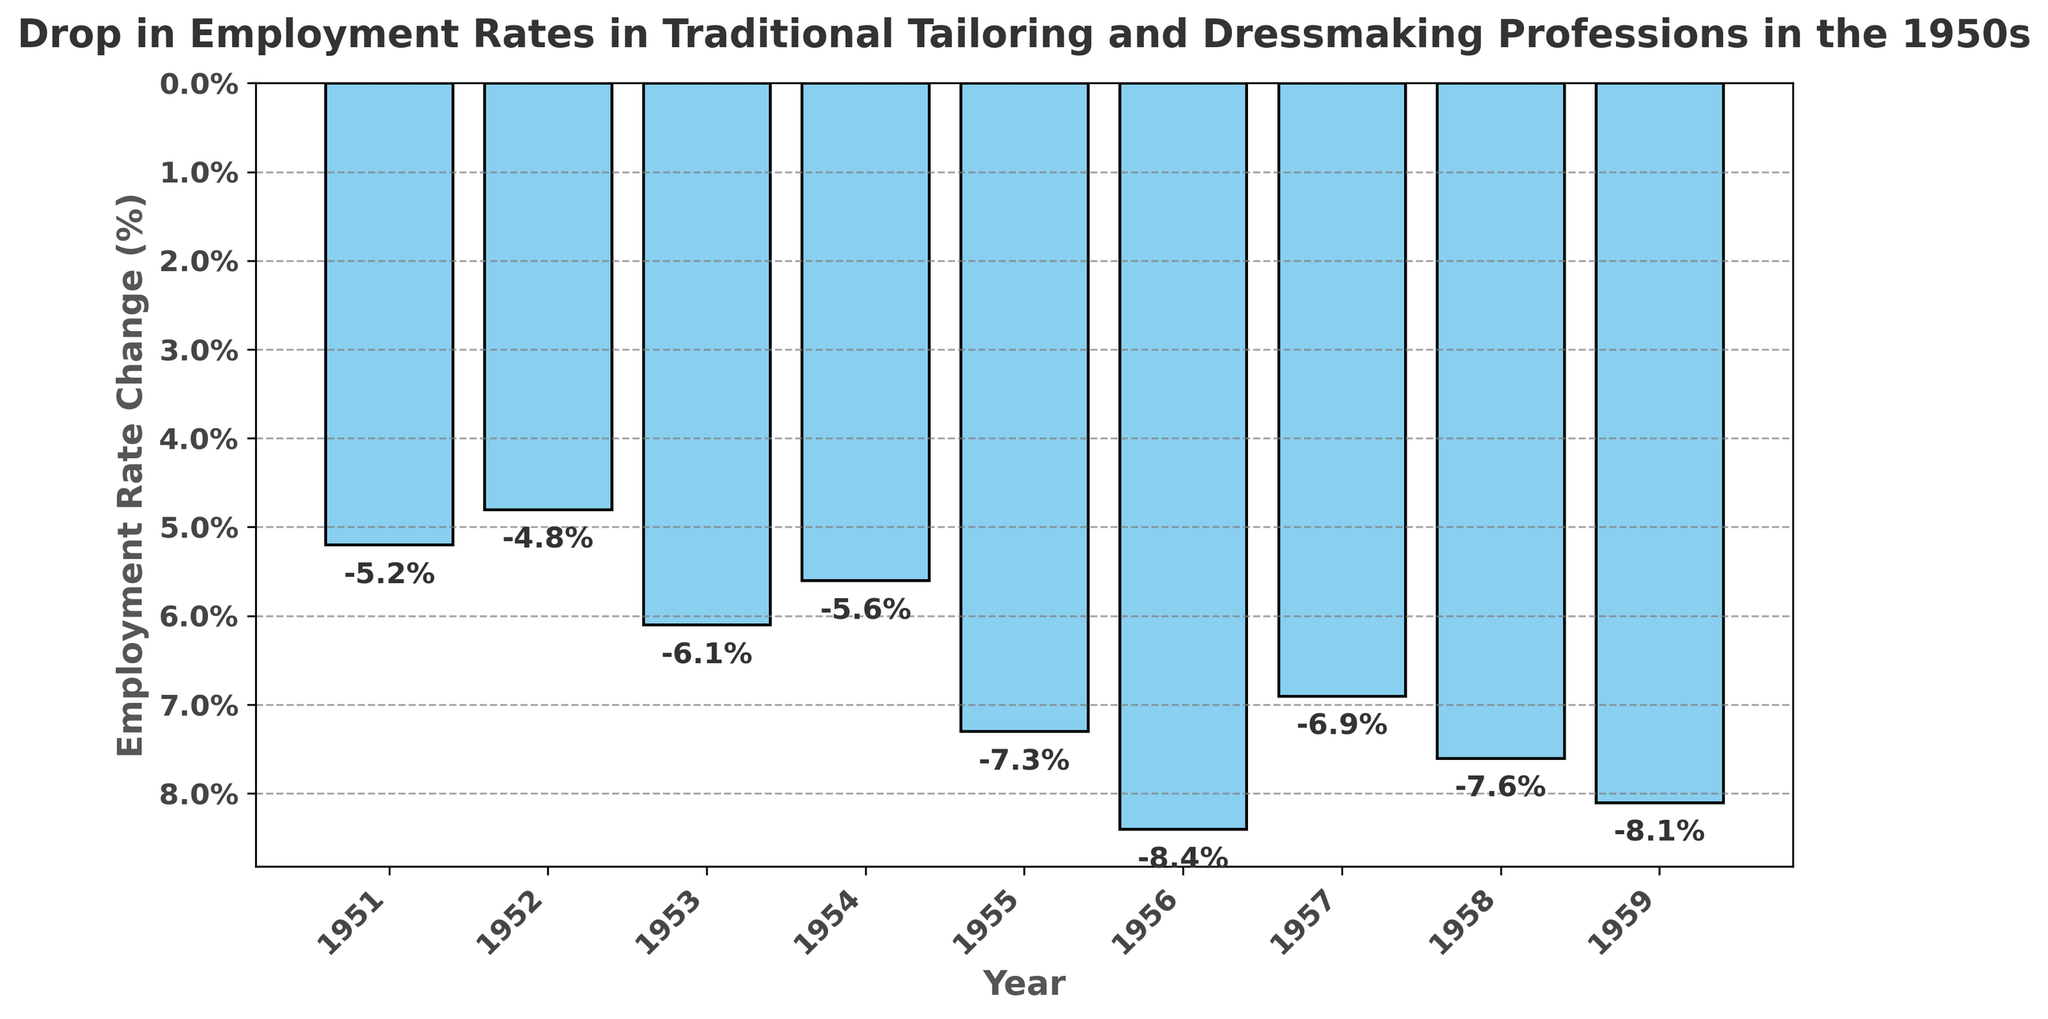What is the average drop in employment rate over the decade? To get the average drop, sum up all the employment rate changes and divide by the number of years. The total drop is (-5.2) + (-4.8) + (-6.1) + (-5.6) + (-7.3) + (-8.4) + (-6.9) + (-7.6) + (-8.1) = -60.0. There are 9 years, so the average drop is -60.0 / 9 = -6.67.
Answer: -6.67% Between which years did the largest single-year drop in employment rate occur? By examining the height of the bars, the largest single-year drop occurs between 1955 and 1956 where the drop changed from -7.3% to -8.4%, a difference of 1.1 percentage points.
Answer: 1955 to 1956 Which year had the smallest decrease in the employment rate? The year with the shortest bar represents the smallest decrease in the employment rate, which visually is 1952 with a drop of -4.8%.
Answer: 1952 Which year experienced a larger decrease in employment rate, 1957 or 1958? By comparing the heights of the bars for 1957 and 1958, 1958 experienced a larger decrease (-7.6%) compared to 1957 (-6.9%).
Answer: 1958 What is the total drop in employment rate over the first five years (1951-1955)? To get the total drop over the first five years, sum the drops for 1951 to 1955: (-5.2) + (-4.8) + (-6.1) + (-5.6) + (-7.3) = -29.0%.
Answer: -29.0% Which two consecutive years have the most similar drops in employment rate? By comparing the heights of consecutive bars, 1953 and 1954 have the most similar drops at -6.1% and -5.6% respectively, a difference of only 0.5 percentage points.
Answer: 1953 and 1954 How much did the employment rate drop in the last three years (1957-1959)? To find the total drop in the last three years, sum the changes: (-6.9) + (-7.6) + (-8.1) = -22.6%.
Answer: -22.6% How many years experienced a drop of more than 7% in employment rate? Visually counting the bars exceeding the -7% mark, these are 1955, 1956, 1958, and 1959. So, 4 years experienced a drop of more than 7%.
Answer: 4 years Was the employment drop in 1956 greater than the average drop over the decade? First calculate the average drop (-6.67%). Then compare it with the drop in 1956 (-8.4%), which is greater than the average.
Answer: Yes 